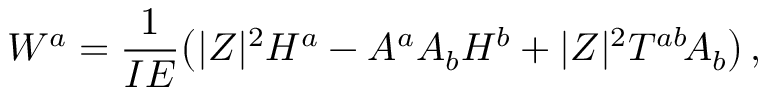Convert formula to latex. <formula><loc_0><loc_0><loc_500><loc_500>W ^ { a } = \frac { 1 } { I E } \left ( | Z | ^ { 2 } H ^ { a } - A ^ { a } A _ { b } H ^ { b } + | Z | ^ { 2 } T ^ { a b } \, A _ { b } \right ) \, ,</formula> 